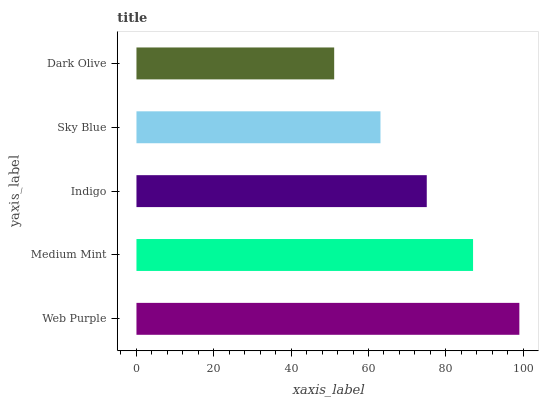Is Dark Olive the minimum?
Answer yes or no. Yes. Is Web Purple the maximum?
Answer yes or no. Yes. Is Medium Mint the minimum?
Answer yes or no. No. Is Medium Mint the maximum?
Answer yes or no. No. Is Web Purple greater than Medium Mint?
Answer yes or no. Yes. Is Medium Mint less than Web Purple?
Answer yes or no. Yes. Is Medium Mint greater than Web Purple?
Answer yes or no. No. Is Web Purple less than Medium Mint?
Answer yes or no. No. Is Indigo the high median?
Answer yes or no. Yes. Is Indigo the low median?
Answer yes or no. Yes. Is Web Purple the high median?
Answer yes or no. No. Is Dark Olive the low median?
Answer yes or no. No. 